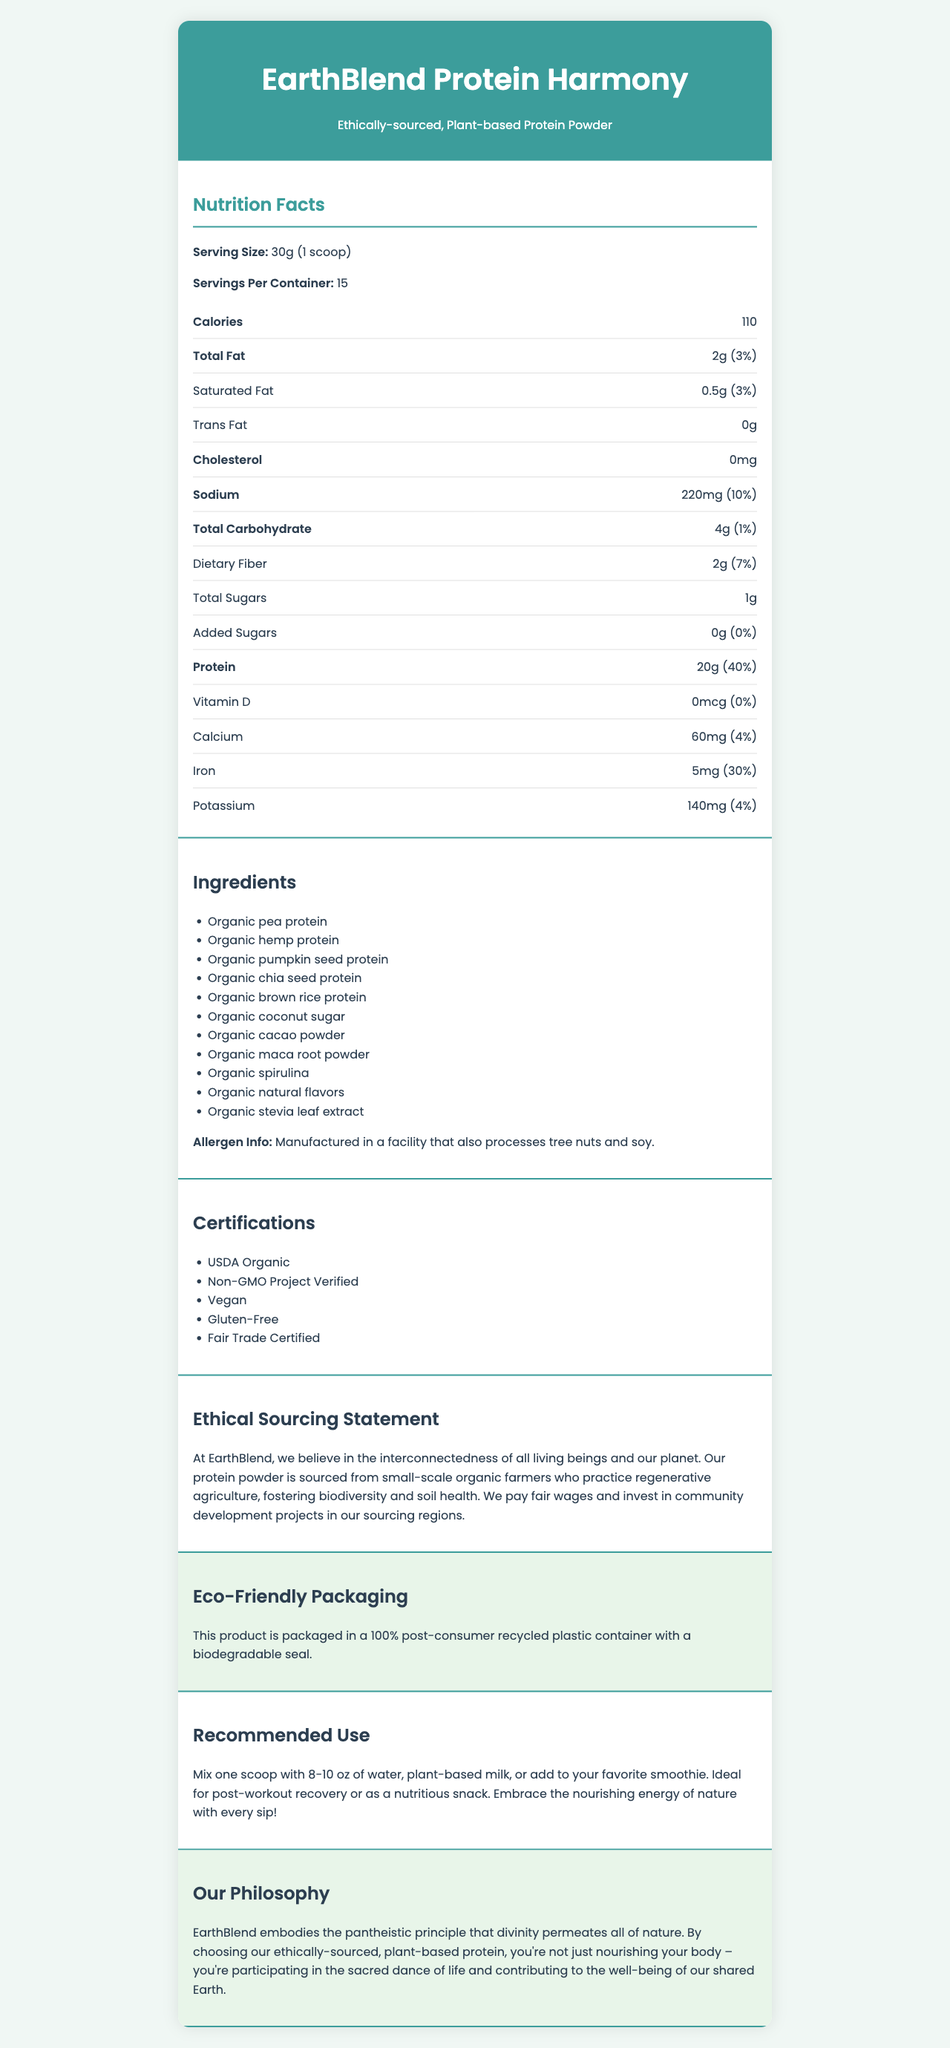What is the serving size of EarthBlend Protein Harmony? The serving size is explicitly mentioned in the "Nutrition Facts" section at the top.
Answer: 30g (1 scoop) How many servings are there per container for EarthBlend Protein Harmony? The "Servings Per Container" is listed under the "Nutrition Facts" section.
Answer: 15 What is the amount of iron per serving in EarthBlend Protein Harmony? The amount of iron is detailed in the "Nutrition Facts" section under the minerals category.
Answer: 5mg Is EarthBlend Protein Harmony high in sodium? Though it contains 220mg of sodium, which is 10% of the daily value, that's not particularly high.
Answer: No Which certification is NOT mentioned for EarthBlend Protein Harmony? A. USDA Organic B. Gluten-Free C. Keto Certified D. Non-GMO Project Verified The document lists "USDA Organic," "Non-GMO Project Verified," "Vegan," "Gluten-Free," and "Fair Trade Certified," but not "Keto Certified."
Answer: C. Keto Certified What is the primary source of protein in EarthBlend Protein Harmony? A. Whey Protein B. Pea Protein C. Soy Protein D. Animal-based Protein The first ingredient listed is "Organic pea protein."
Answer: B. Pea Protein Does EarthBlend Protein Harmony contain any added sugars? According to the "Nutrition Facts," it has 0g of added sugars.
Answer: No Summarize the company philosophy of EarthBlend. The philosophy emphasizes a holistic view that integrates ethical sourcing, sustainability, and the interconnectedness of all life.
Answer: EarthBlend believes in the pantheistic principle that divinity permeates all of nature. By choosing their ethically-sourced, plant-based protein, consumers nourish their bodies and contribute to the well-being of the Earth. What daily value percentage of protein does one serving provide? The document states that there is 20g of protein per serving, which is 40% of the daily value.
Answer: 40% What type of packaging does EarthBlend Protein Harmony use? This information is found in the "Eco-Friendly Packaging" section.
Answer: 100% post-consumer recycled plastic container with a biodegradable seal How much total fat is there in a serving of EarthBlend Protein Harmony? The amount of total fat is found in the "Nutrition Facts" section.
Answer: 2g Is EarthBlend Protein Harmony certified as Gluten-Free? "Gluten-Free" is one of the certifications listed.
Answer: Yes What is the recommended use for EarthBlend Protein Harmony? This information can be found in the "Recommended Use" section.
Answer: Mix one scoop with 8-10 oz of water, plant-based milk, or add to your favorite smoothie. Ideal for post-workout recovery or as a nutritious snack. Does EarthBlend Protein Harmony contain any cholesterol? The cholesterol content listed in the "Nutrition Facts" is 0mg.
Answer: No What is the main source of sweetening in EarthBlend Protein Harmony? The ingredient list includes "Organic coconut sugar."
Answer: Organic coconut sugar Where is EarthBlend Protein Harmony sourced from? This is detailed in the "Ethical Sourcing Statement" section, highlighting the focus on biodiversity and fair wages.
Answer: Small-scale organic farmers practicing regenerative agriculture How much calcium is in one serving of EarthBlend Protein Harmony? The calcium amount is listed in the "Nutrition Facts" section.
Answer: 60mg Does EarthBlend Protein Harmony contain tree nuts or soy? While it does not explicitly state the product contains these allergens, it is manufactured in a facility that processes them.
Answer: Manufactured in a facility that processes tree nuts and soy. How much dietary fiber is in one serving of EarthBlend Protein Harmony? The dietary fiber content is listed in the "Nutrition Facts" section.
Answer: 2g What is the product name? The product name is prominently displayed at the top of the document.
Answer: EarthBlend Protein Harmony What form of agriculture does EarthBlend promote? The ethical sourcing statement explains that the protein powder is sourced from farmers practicing regenerative agriculture.
Answer: Regenerative agriculture What is the source of Vitamin D in this product? The document lists the Vitamin D content as 0mcg, implying there is none, but it does not explain the source or lack thereof.
Answer: Cannot be determined What’s the amount of saturated fat per serving, and its daily value percentage? The saturated fat content is listed in the "Nutrition Facts" section.
Answer: 0.5g (3%) What does EarthBlend Protein Harmony represent according to the company philosophy? A. Technological innovation B. Individual success C. Pantheistic principle D. Financial growth The company philosophy section articulates that EarthBlend represents the pantheistic principle that divinity permeates all nature.
Answer: C. Pantheistic principle How many grams of total carbohydrates are there in one serving of EarthBlend Protein Harmony? The total carbohydrate amount is specified in the "Nutrition Facts" section.
Answer: 4g 